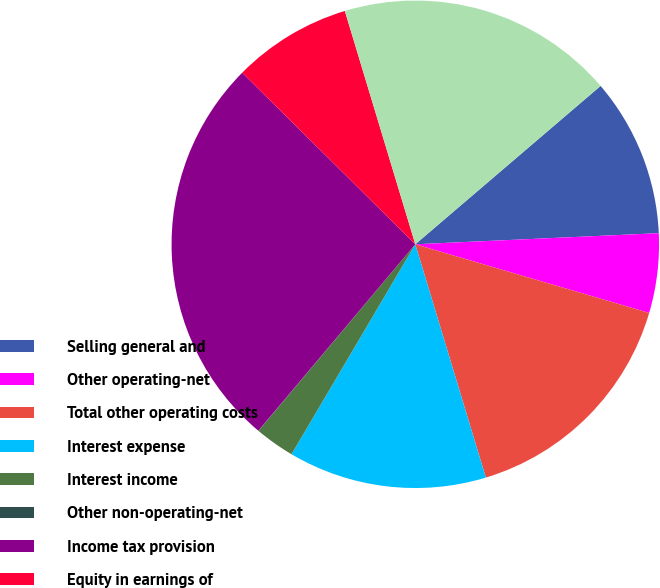Convert chart. <chart><loc_0><loc_0><loc_500><loc_500><pie_chart><fcel>Selling general and<fcel>Other operating-net<fcel>Total other operating costs<fcel>Interest expense<fcel>Interest income<fcel>Other non-operating-net<fcel>Income tax provision<fcel>Equity in earnings of<fcel>Less Net earnings attributable<nl><fcel>10.53%<fcel>5.27%<fcel>15.78%<fcel>13.15%<fcel>2.64%<fcel>0.02%<fcel>26.29%<fcel>7.9%<fcel>18.41%<nl></chart> 